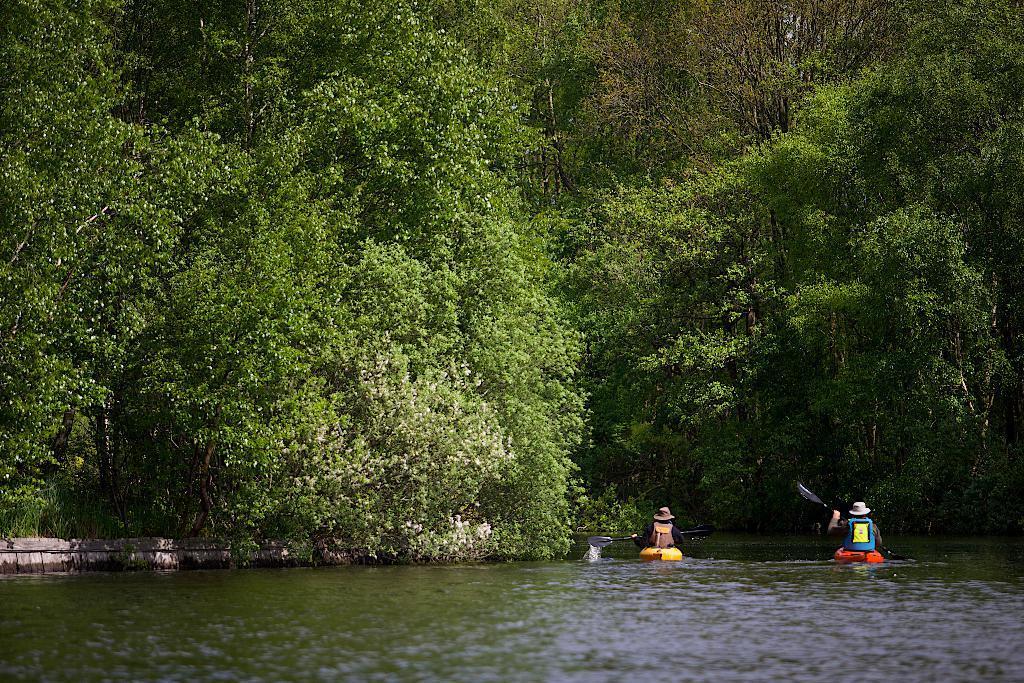Can you describe this image briefly? At the bottom, I can see the water. On the right side there are two persons holding paddles in the hands and sitting on the boats. In the background there are many trees. 